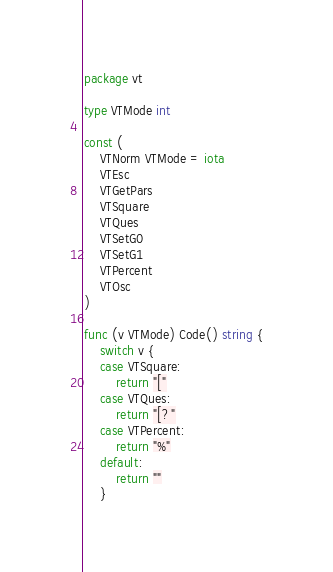Convert code to text. <code><loc_0><loc_0><loc_500><loc_500><_Go_>package vt

type VTMode int

const (
	VTNorm VTMode = iota
	VTEsc
	VTGetPars
	VTSquare
	VTQues
	VTSetG0
	VTSetG1
	VTPercent
	VTOsc
)

func (v VTMode) Code() string {
	switch v {
	case VTSquare:
		return "["
	case VTQues:
		return "[?"
	case VTPercent:
		return "%"
	default:
		return ""
	}</code> 